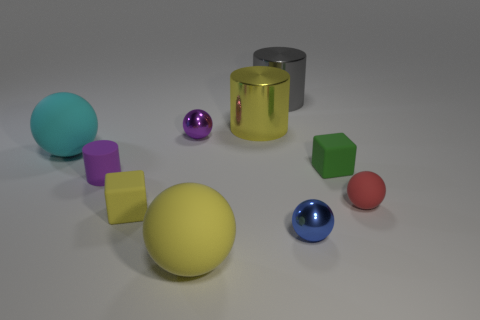There is a yellow thing that is the same size as the red ball; what material is it?
Give a very brief answer. Rubber. Is the size of the rubber ball that is behind the red sphere the same as the green cube?
Make the answer very short. No. What number of balls are gray objects or large things?
Ensure brevity in your answer.  2. There is a object right of the green block; what is its material?
Your answer should be very brief. Rubber. Are there fewer purple cylinders than tiny things?
Your response must be concise. Yes. How big is the shiny thing that is both behind the small purple metallic thing and in front of the big gray thing?
Your response must be concise. Large. There is a cylinder that is on the left side of the big rubber object that is in front of the small yellow cube that is right of the rubber cylinder; what is its size?
Your response must be concise. Small. What number of other things are the same color as the small cylinder?
Ensure brevity in your answer.  1. Does the tiny rubber cube to the left of the big yellow sphere have the same color as the matte cylinder?
Your answer should be compact. No. What number of objects are large yellow shiny spheres or big rubber balls?
Provide a succinct answer. 2. 